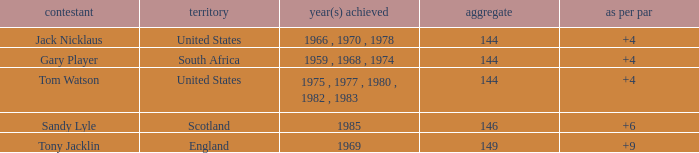What player had a To par smaller than 9 and won in 1985? Sandy Lyle. 